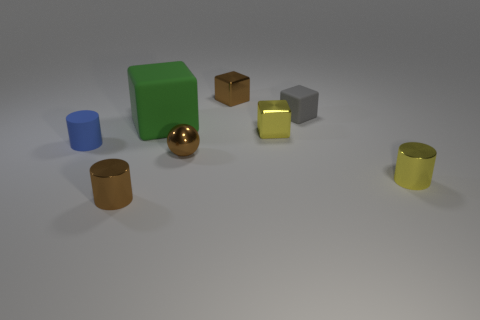Add 1 small yellow metal objects. How many objects exist? 9 Subtract all balls. How many objects are left? 7 Add 4 tiny brown metallic cylinders. How many tiny brown metallic cylinders are left? 5 Add 2 tiny rubber spheres. How many tiny rubber spheres exist? 2 Subtract 0 red cubes. How many objects are left? 8 Subtract all small red balls. Subtract all small things. How many objects are left? 1 